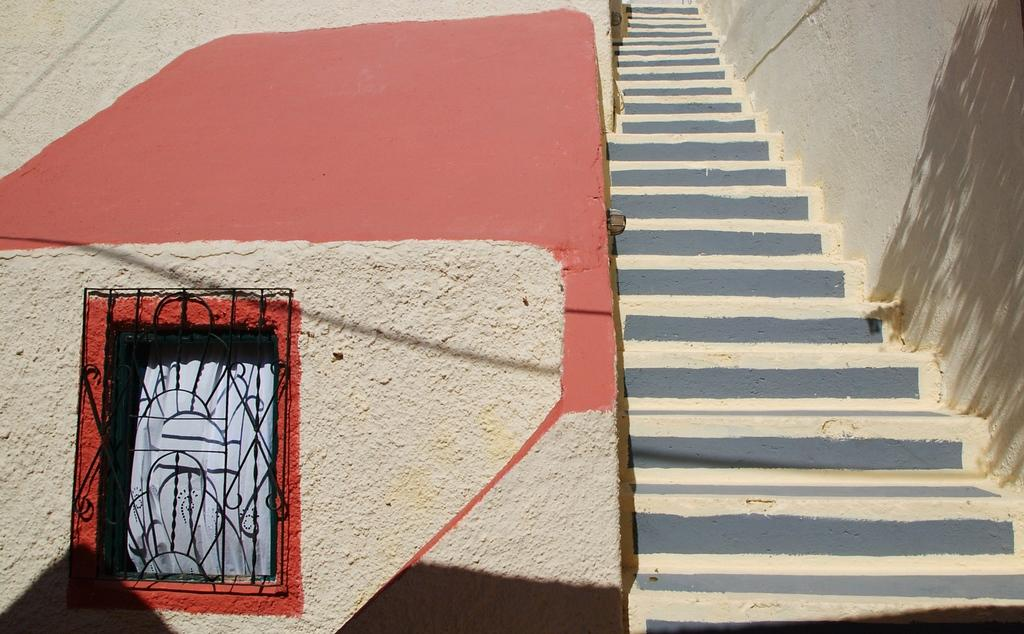What type of architectural feature can be seen in the image? There are stairs in the image. What other structural elements are present in the image? There are walls in the image. Is there any source of natural light visible in the image? Yes, there is a window in the image. What can be seen through the window holes? There is a curtain visible through the window holes. What is the temperature limit for the hot air balloon in the image? There is no hot air balloon present in the image, so it is not possible to determine a temperature limit. 